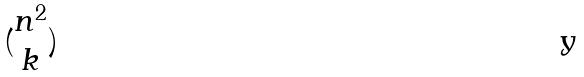<formula> <loc_0><loc_0><loc_500><loc_500>( \begin{matrix} n ^ { 2 } \\ k \end{matrix} )</formula> 